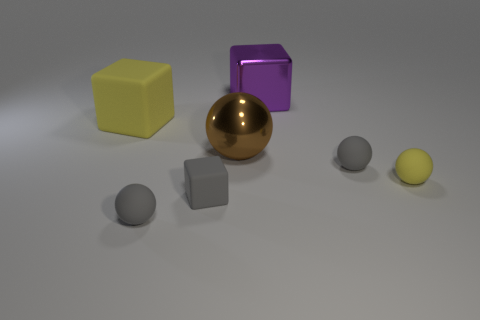Subtract all large cubes. How many cubes are left? 1 Add 3 large brown things. How many objects exist? 10 Subtract all yellow blocks. How many gray balls are left? 2 Subtract all purple cubes. How many cubes are left? 2 Subtract 3 cubes. How many cubes are left? 0 Subtract 1 yellow blocks. How many objects are left? 6 Subtract all spheres. How many objects are left? 3 Subtract all blue cubes. Subtract all purple cylinders. How many cubes are left? 3 Subtract all small matte spheres. Subtract all yellow cubes. How many objects are left? 3 Add 3 large yellow cubes. How many large yellow cubes are left? 4 